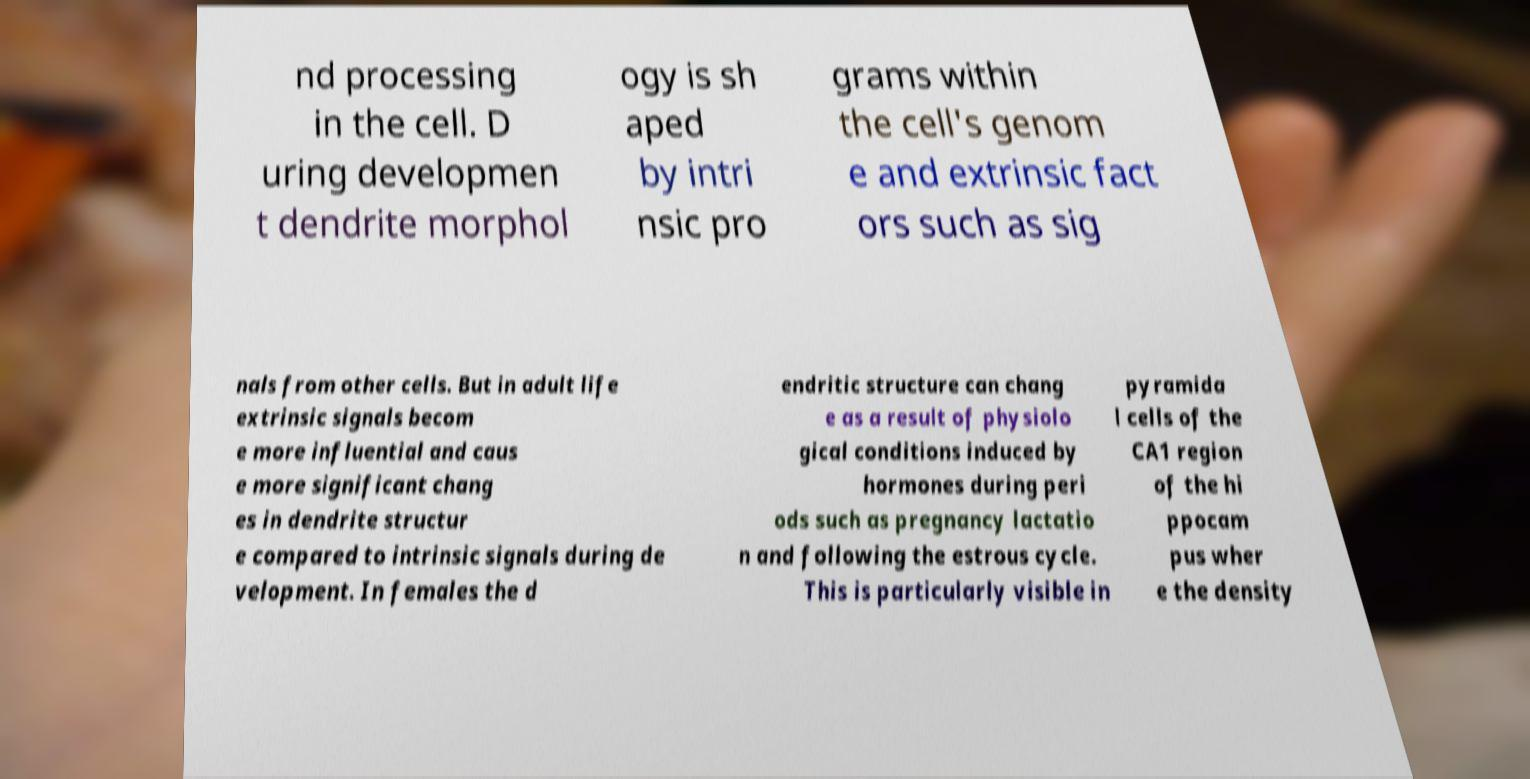Can you accurately transcribe the text from the provided image for me? nd processing in the cell. D uring developmen t dendrite morphol ogy is sh aped by intri nsic pro grams within the cell's genom e and extrinsic fact ors such as sig nals from other cells. But in adult life extrinsic signals becom e more influential and caus e more significant chang es in dendrite structur e compared to intrinsic signals during de velopment. In females the d endritic structure can chang e as a result of physiolo gical conditions induced by hormones during peri ods such as pregnancy lactatio n and following the estrous cycle. This is particularly visible in pyramida l cells of the CA1 region of the hi ppocam pus wher e the density 